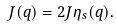<formula> <loc_0><loc_0><loc_500><loc_500>J ( { q } ) = 2 J \eta _ { s } ( { q } ) .</formula> 